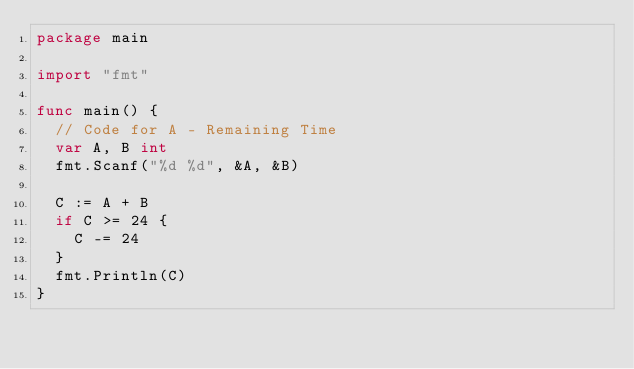Convert code to text. <code><loc_0><loc_0><loc_500><loc_500><_Go_>package main

import "fmt"

func main() {
	// Code for A - Remaining Time
	var A, B int
	fmt.Scanf("%d %d", &A, &B)

	C := A + B
	if C >= 24 {
		C -= 24
	}
	fmt.Println(C)
}
</code> 